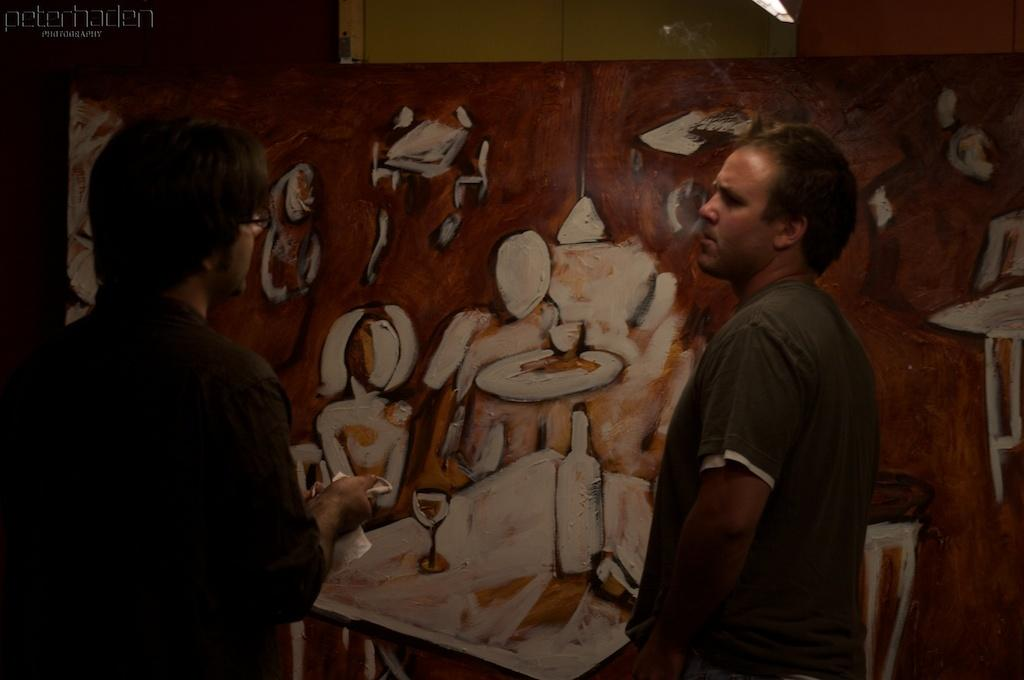What is the main subject in the image? There is a painting in the image. Can you describe the people in the image? There are two people standing in the image. What type of stove is visible in the image? There is no stove present in the image. What is the chain used for in the image? There is no chain present in the image. 